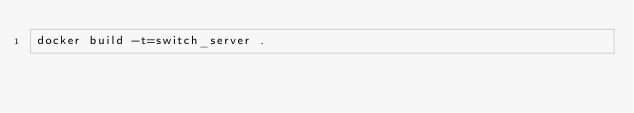Convert code to text. <code><loc_0><loc_0><loc_500><loc_500><_Bash_>docker build -t=switch_server .
</code> 